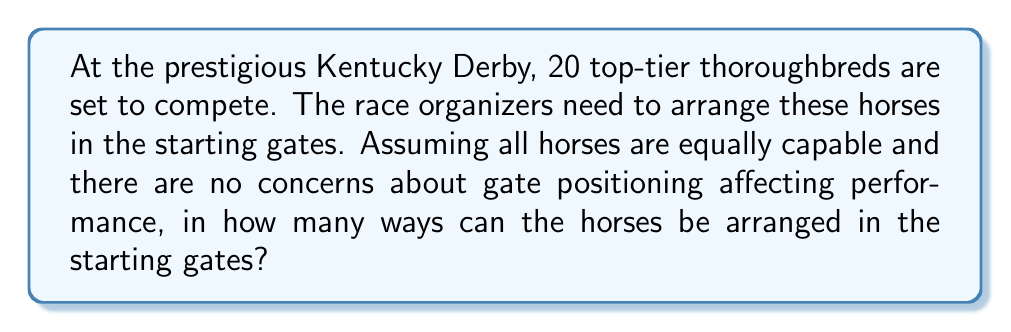What is the answer to this math problem? Let's approach this step-by-step:

1) We have 20 distinct horses that need to be arranged in a specific order.

2) This is a classic permutation problem. We are arranging all 20 horses, and the order matters.

3) For the first position, we have 20 choices.

4) After placing the first horse, we have 19 choices for the second position.

5) This continues until we place the last horse, where we have only 1 choice left.

6) Mathematically, this is represented as:

   $$20 \times 19 \times 18 \times ... \times 2 \times 1$$

7) This is the definition of 20 factorial, denoted as 20!

8) Therefore, the number of ways to arrange 20 horses in the starting gates is:

   $$20! = 2,432,902,008,176,640,000$$

This astronomical number showcases the vast number of possible race configurations, highlighting the unpredictable nature of horse racing and reinforcing the idea that all horses have an equal opportunity at the starting line.
Answer: $20!$ 